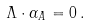Convert formula to latex. <formula><loc_0><loc_0><loc_500><loc_500>\Lambda \cdot \alpha _ { A } = 0 \, .</formula> 